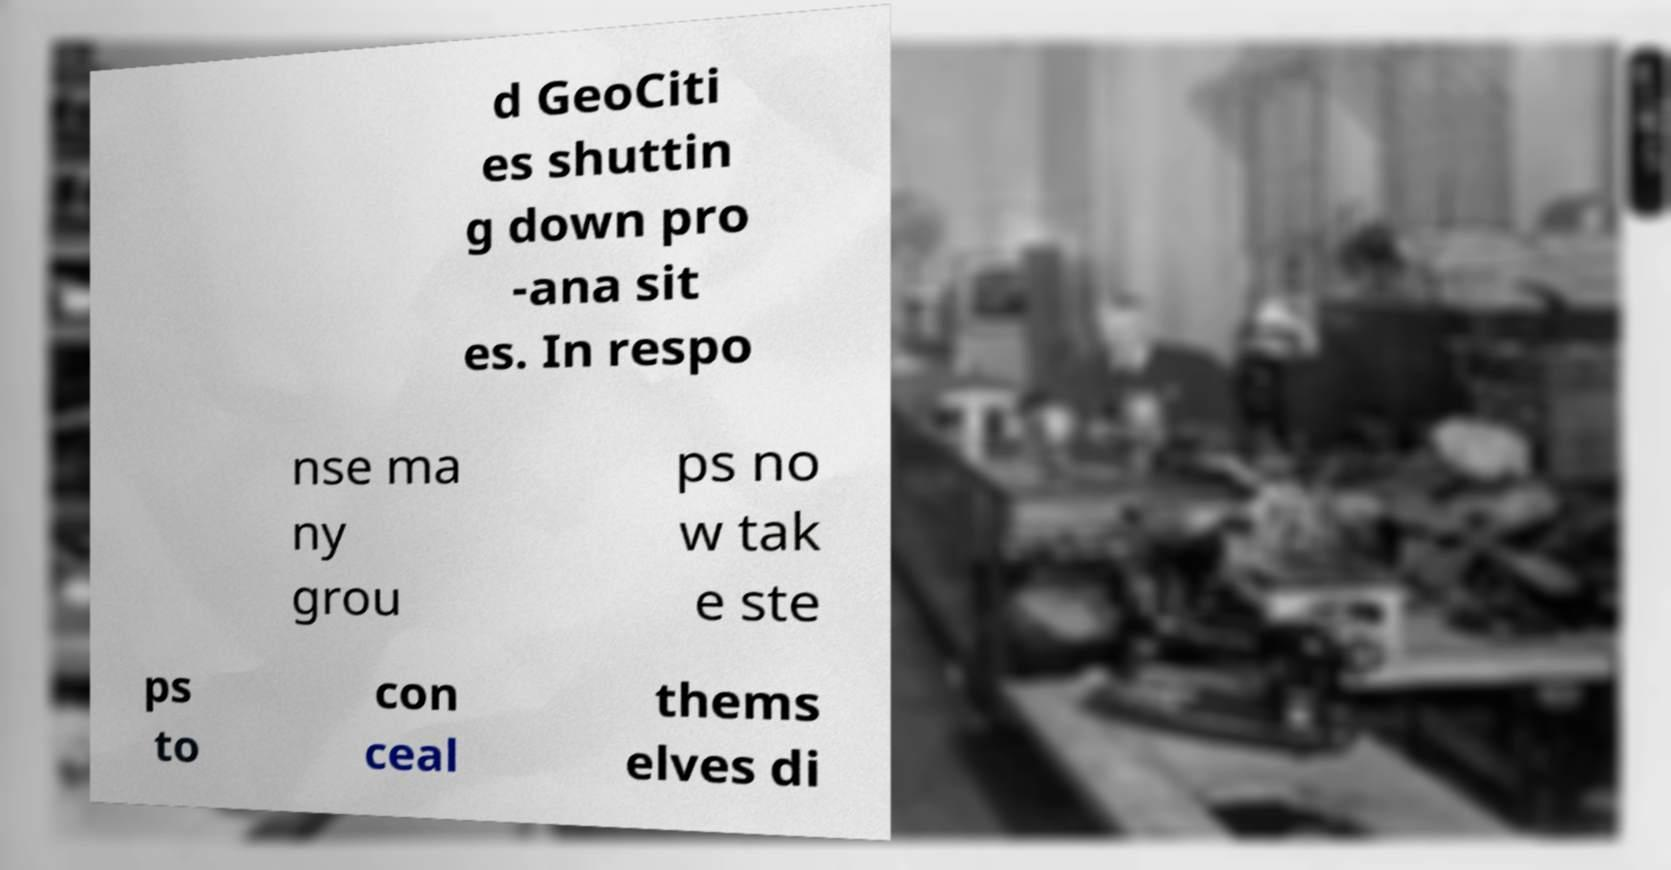For documentation purposes, I need the text within this image transcribed. Could you provide that? d GeoCiti es shuttin g down pro -ana sit es. In respo nse ma ny grou ps no w tak e ste ps to con ceal thems elves di 